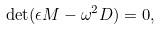<formula> <loc_0><loc_0><loc_500><loc_500>\det ( \epsilon { M } - \omega ^ { 2 } { D } ) = 0 ,</formula> 